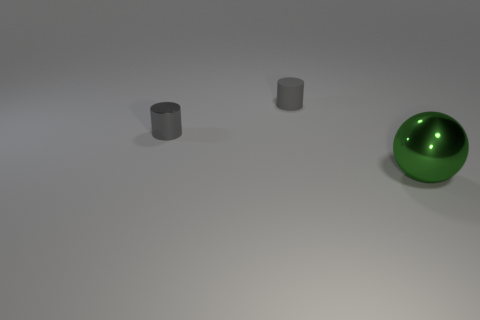Add 3 tiny metal cylinders. How many objects exist? 6 Subtract all balls. How many objects are left? 2 Subtract 0 cyan blocks. How many objects are left? 3 Subtract all balls. Subtract all big green metal cylinders. How many objects are left? 2 Add 3 rubber cylinders. How many rubber cylinders are left? 4 Add 2 large brown blocks. How many large brown blocks exist? 2 